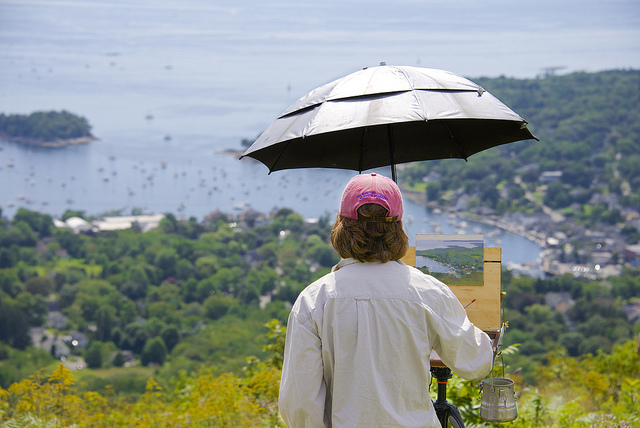Can you tell me more about what the person is painting? In the image, it seems the person is painting a landscape, capturing the view of the harbor below. The placement of the canvas aligned with the view suggests they are likely portraying the picturesque scenery in front of them. Is there anything unique about their painting style that can be observed from this distance? From this vantage point, it's difficult to discern specific details of the painting style. However, the choice to paint outdoors, known as en plein air painting, often leads artists to adopt a looser, more impressionistic style that captures the transient qualities of light and atmosphere. 